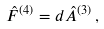<formula> <loc_0><loc_0><loc_500><loc_500>\hat { F } ^ { ( 4 ) } = d \hat { A } ^ { ( 3 ) } \, ,</formula> 